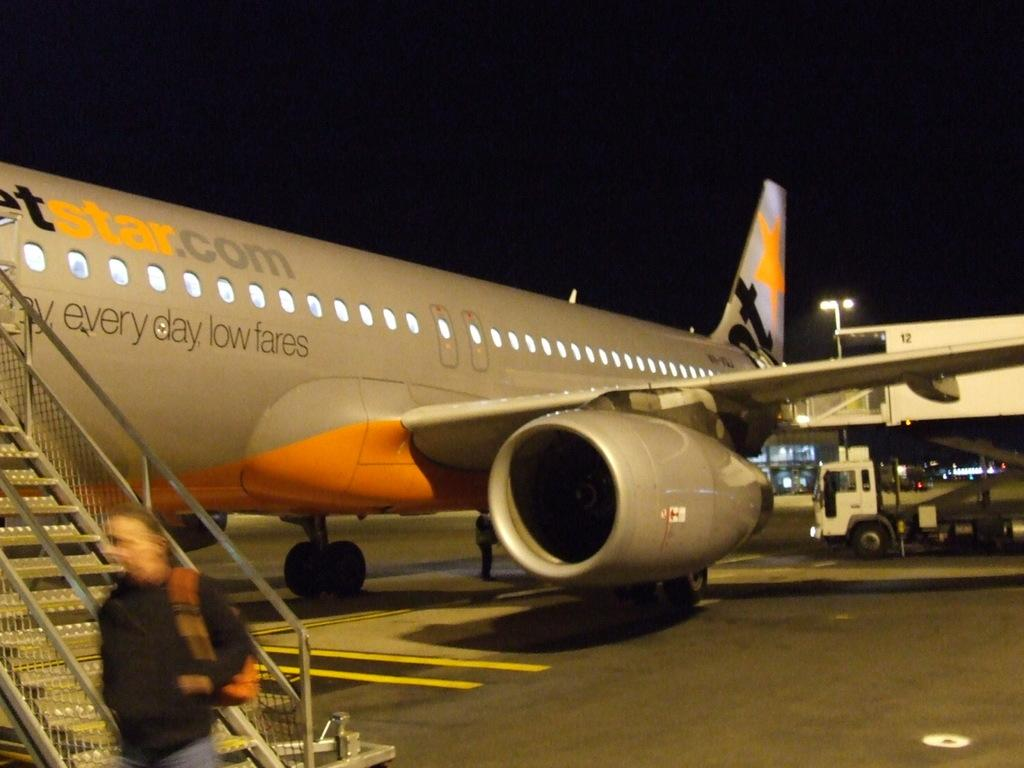<image>
Render a clear and concise summary of the photo. A plan displaying a message for every day low fares 